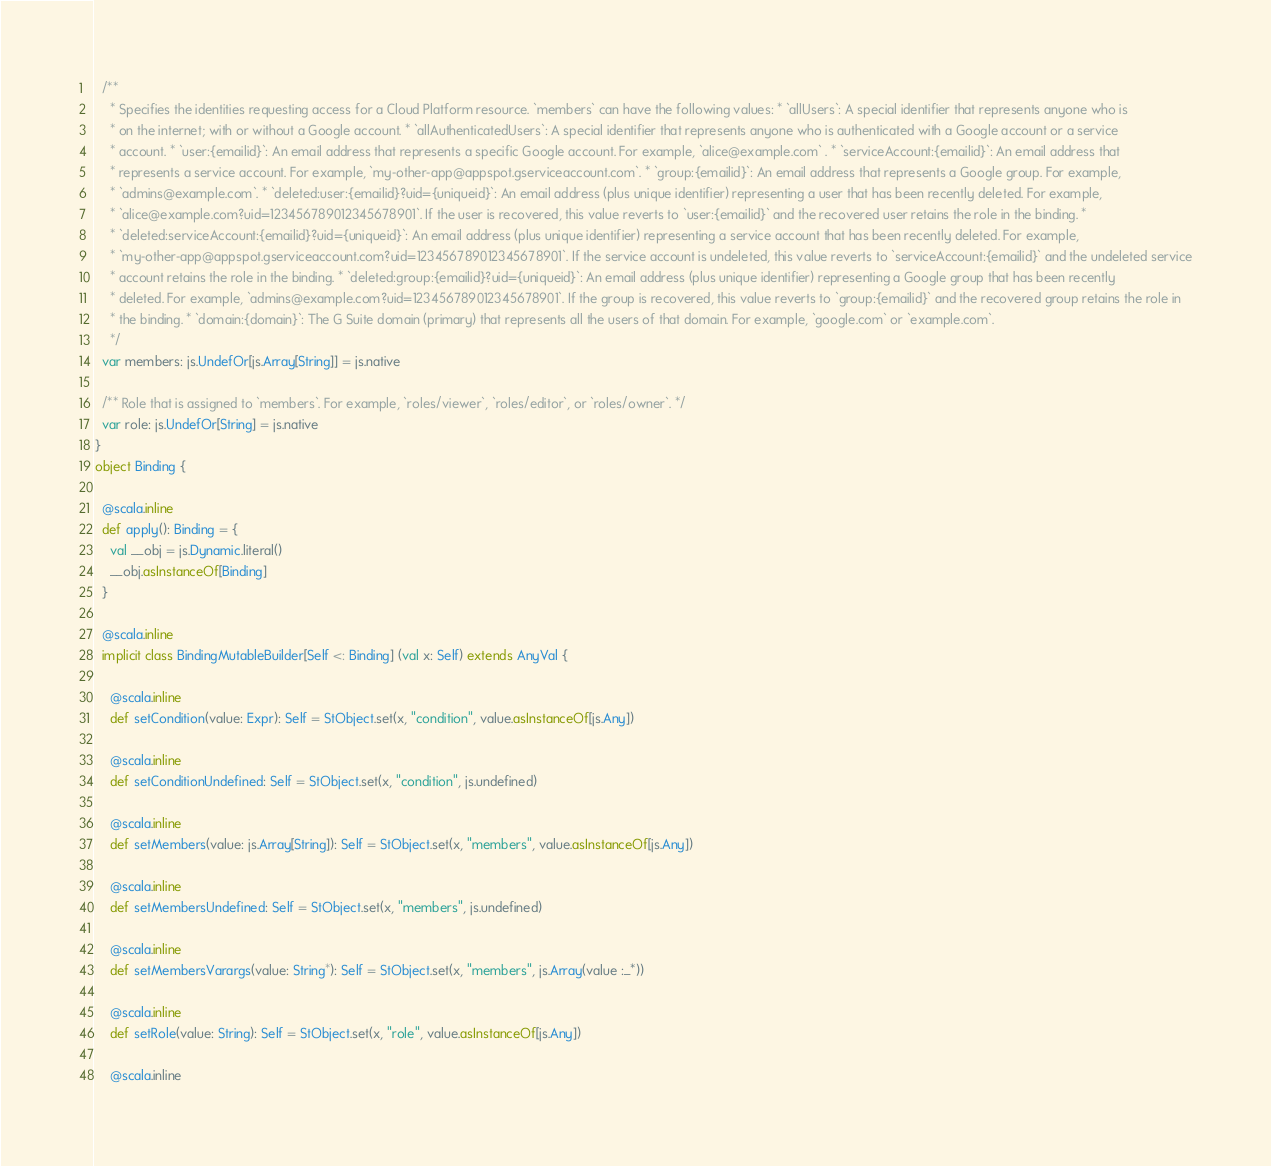<code> <loc_0><loc_0><loc_500><loc_500><_Scala_>  /**
    * Specifies the identities requesting access for a Cloud Platform resource. `members` can have the following values: * `allUsers`: A special identifier that represents anyone who is
    * on the internet; with or without a Google account. * `allAuthenticatedUsers`: A special identifier that represents anyone who is authenticated with a Google account or a service
    * account. * `user:{emailid}`: An email address that represents a specific Google account. For example, `alice@example.com` . * `serviceAccount:{emailid}`: An email address that
    * represents a service account. For example, `my-other-app@appspot.gserviceaccount.com`. * `group:{emailid}`: An email address that represents a Google group. For example,
    * `admins@example.com`. * `deleted:user:{emailid}?uid={uniqueid}`: An email address (plus unique identifier) representing a user that has been recently deleted. For example,
    * `alice@example.com?uid=123456789012345678901`. If the user is recovered, this value reverts to `user:{emailid}` and the recovered user retains the role in the binding. *
    * `deleted:serviceAccount:{emailid}?uid={uniqueid}`: An email address (plus unique identifier) representing a service account that has been recently deleted. For example,
    * `my-other-app@appspot.gserviceaccount.com?uid=123456789012345678901`. If the service account is undeleted, this value reverts to `serviceAccount:{emailid}` and the undeleted service
    * account retains the role in the binding. * `deleted:group:{emailid}?uid={uniqueid}`: An email address (plus unique identifier) representing a Google group that has been recently
    * deleted. For example, `admins@example.com?uid=123456789012345678901`. If the group is recovered, this value reverts to `group:{emailid}` and the recovered group retains the role in
    * the binding. * `domain:{domain}`: The G Suite domain (primary) that represents all the users of that domain. For example, `google.com` or `example.com`.
    */
  var members: js.UndefOr[js.Array[String]] = js.native
  
  /** Role that is assigned to `members`. For example, `roles/viewer`, `roles/editor`, or `roles/owner`. */
  var role: js.UndefOr[String] = js.native
}
object Binding {
  
  @scala.inline
  def apply(): Binding = {
    val __obj = js.Dynamic.literal()
    __obj.asInstanceOf[Binding]
  }
  
  @scala.inline
  implicit class BindingMutableBuilder[Self <: Binding] (val x: Self) extends AnyVal {
    
    @scala.inline
    def setCondition(value: Expr): Self = StObject.set(x, "condition", value.asInstanceOf[js.Any])
    
    @scala.inline
    def setConditionUndefined: Self = StObject.set(x, "condition", js.undefined)
    
    @scala.inline
    def setMembers(value: js.Array[String]): Self = StObject.set(x, "members", value.asInstanceOf[js.Any])
    
    @scala.inline
    def setMembersUndefined: Self = StObject.set(x, "members", js.undefined)
    
    @scala.inline
    def setMembersVarargs(value: String*): Self = StObject.set(x, "members", js.Array(value :_*))
    
    @scala.inline
    def setRole(value: String): Self = StObject.set(x, "role", value.asInstanceOf[js.Any])
    
    @scala.inline</code> 